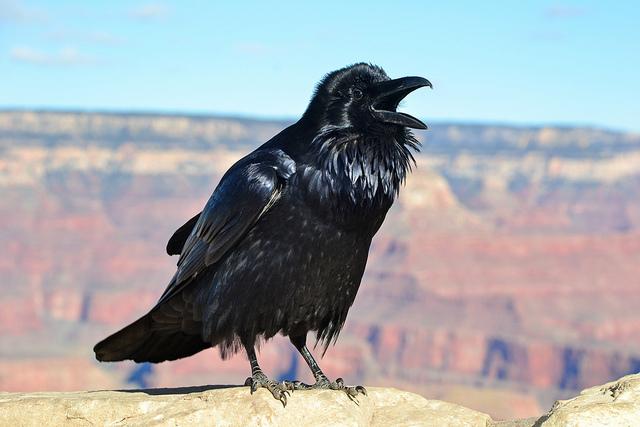Where is this bird?
Concise answer only. Grand canyon. What is the bird about to do next?
Short answer required. Fly. Is this bird making noise?
Short answer required. Yes. What color is this bird?
Keep it brief. Black. 